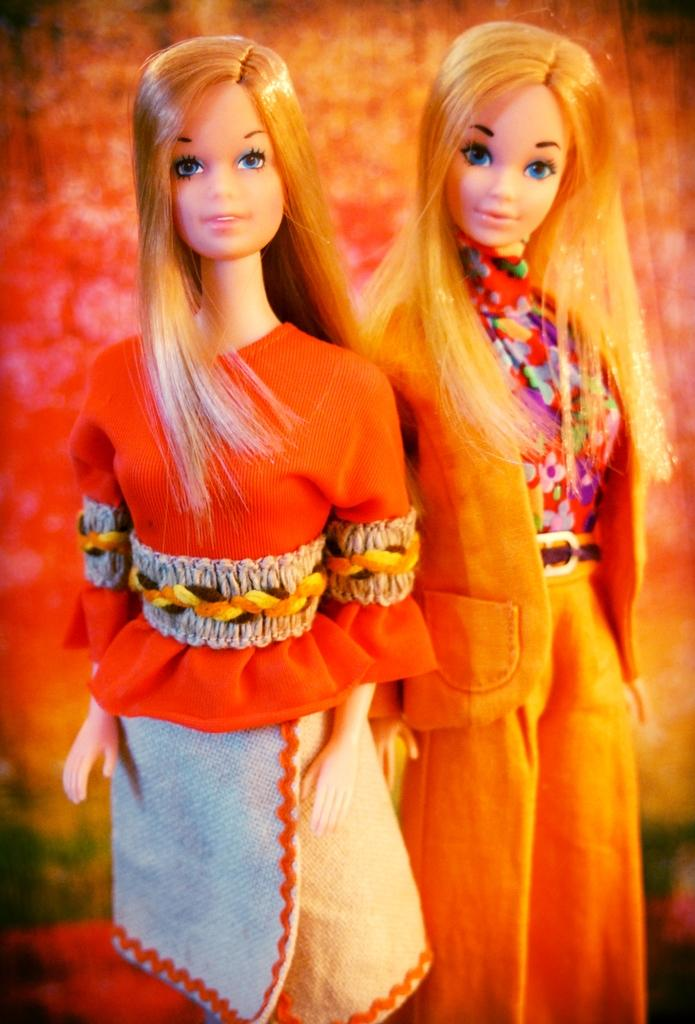How many dolls are present in the image? There are two dolls in the image. What is the color of the dress worn by the doll on the right side? The doll on the right side is wearing an orange dress. What is the color of the dress worn by the doll on the left side? The doll on the left side is wearing a red dress. What type of nut is being used as a vessel for the doll on the left side? There is no nut or vessel present in the image; the dolls are not interacting with any objects other than their dresses. 